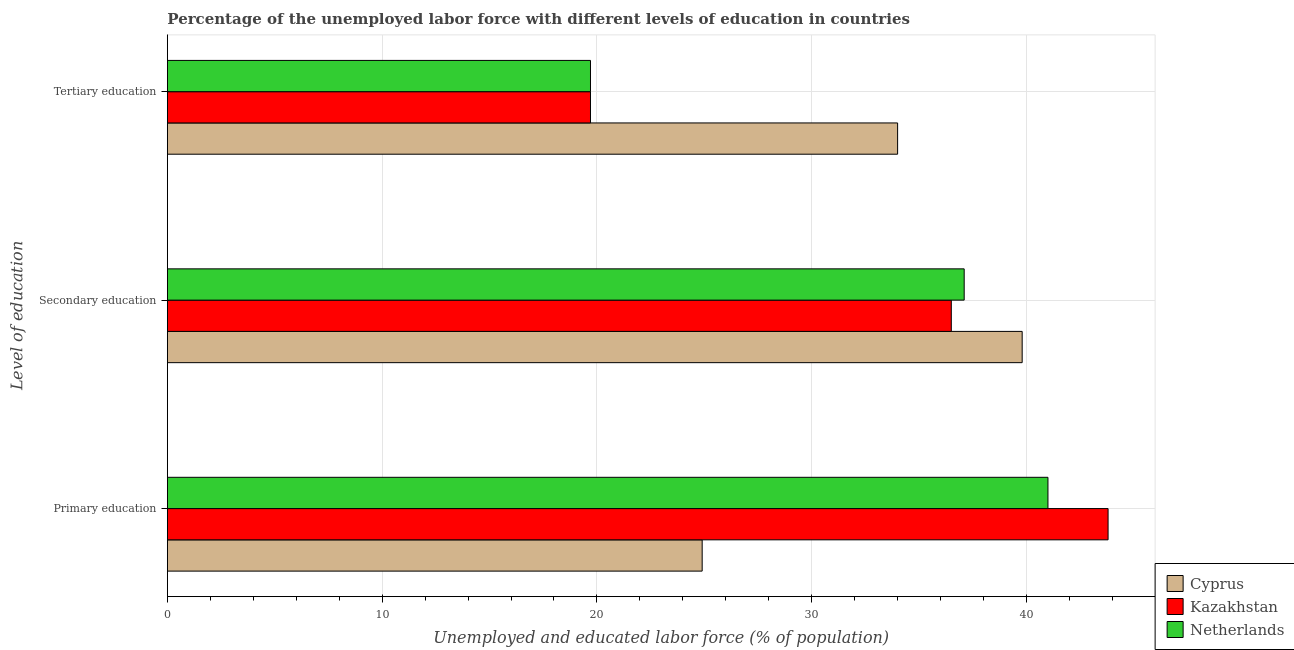How many groups of bars are there?
Offer a terse response. 3. Are the number of bars per tick equal to the number of legend labels?
Provide a succinct answer. Yes. How many bars are there on the 3rd tick from the top?
Provide a succinct answer. 3. What is the label of the 3rd group of bars from the top?
Keep it short and to the point. Primary education. What is the percentage of labor force who received secondary education in Netherlands?
Provide a succinct answer. 37.1. Across all countries, what is the maximum percentage of labor force who received secondary education?
Keep it short and to the point. 39.8. Across all countries, what is the minimum percentage of labor force who received secondary education?
Provide a succinct answer. 36.5. In which country was the percentage of labor force who received secondary education maximum?
Offer a very short reply. Cyprus. In which country was the percentage of labor force who received secondary education minimum?
Ensure brevity in your answer.  Kazakhstan. What is the total percentage of labor force who received secondary education in the graph?
Your response must be concise. 113.4. What is the difference between the percentage of labor force who received primary education in Kazakhstan and that in Netherlands?
Ensure brevity in your answer.  2.8. What is the difference between the percentage of labor force who received primary education in Cyprus and the percentage of labor force who received secondary education in Kazakhstan?
Ensure brevity in your answer.  -11.6. What is the average percentage of labor force who received primary education per country?
Your response must be concise. 36.57. What is the difference between the percentage of labor force who received primary education and percentage of labor force who received secondary education in Netherlands?
Give a very brief answer. 3.9. In how many countries, is the percentage of labor force who received primary education greater than 36 %?
Offer a terse response. 2. What is the ratio of the percentage of labor force who received primary education in Kazakhstan to that in Cyprus?
Keep it short and to the point. 1.76. Is the difference between the percentage of labor force who received tertiary education in Netherlands and Kazakhstan greater than the difference between the percentage of labor force who received secondary education in Netherlands and Kazakhstan?
Your answer should be compact. No. What is the difference between the highest and the second highest percentage of labor force who received secondary education?
Offer a terse response. 2.7. What is the difference between the highest and the lowest percentage of labor force who received primary education?
Offer a very short reply. 18.9. In how many countries, is the percentage of labor force who received primary education greater than the average percentage of labor force who received primary education taken over all countries?
Offer a very short reply. 2. What does the 2nd bar from the top in Secondary education represents?
Make the answer very short. Kazakhstan. What does the 2nd bar from the bottom in Primary education represents?
Give a very brief answer. Kazakhstan. Are all the bars in the graph horizontal?
Your answer should be very brief. Yes. How many countries are there in the graph?
Your response must be concise. 3. Does the graph contain any zero values?
Provide a succinct answer. No. How many legend labels are there?
Offer a very short reply. 3. What is the title of the graph?
Give a very brief answer. Percentage of the unemployed labor force with different levels of education in countries. Does "Puerto Rico" appear as one of the legend labels in the graph?
Offer a very short reply. No. What is the label or title of the X-axis?
Ensure brevity in your answer.  Unemployed and educated labor force (% of population). What is the label or title of the Y-axis?
Keep it short and to the point. Level of education. What is the Unemployed and educated labor force (% of population) of Cyprus in Primary education?
Your response must be concise. 24.9. What is the Unemployed and educated labor force (% of population) of Kazakhstan in Primary education?
Offer a very short reply. 43.8. What is the Unemployed and educated labor force (% of population) in Cyprus in Secondary education?
Ensure brevity in your answer.  39.8. What is the Unemployed and educated labor force (% of population) of Kazakhstan in Secondary education?
Offer a terse response. 36.5. What is the Unemployed and educated labor force (% of population) of Netherlands in Secondary education?
Ensure brevity in your answer.  37.1. What is the Unemployed and educated labor force (% of population) in Cyprus in Tertiary education?
Give a very brief answer. 34. What is the Unemployed and educated labor force (% of population) in Kazakhstan in Tertiary education?
Provide a short and direct response. 19.7. What is the Unemployed and educated labor force (% of population) of Netherlands in Tertiary education?
Your response must be concise. 19.7. Across all Level of education, what is the maximum Unemployed and educated labor force (% of population) in Cyprus?
Keep it short and to the point. 39.8. Across all Level of education, what is the maximum Unemployed and educated labor force (% of population) of Kazakhstan?
Offer a very short reply. 43.8. Across all Level of education, what is the minimum Unemployed and educated labor force (% of population) of Cyprus?
Provide a succinct answer. 24.9. Across all Level of education, what is the minimum Unemployed and educated labor force (% of population) in Kazakhstan?
Make the answer very short. 19.7. Across all Level of education, what is the minimum Unemployed and educated labor force (% of population) of Netherlands?
Your answer should be compact. 19.7. What is the total Unemployed and educated labor force (% of population) in Cyprus in the graph?
Provide a succinct answer. 98.7. What is the total Unemployed and educated labor force (% of population) of Netherlands in the graph?
Keep it short and to the point. 97.8. What is the difference between the Unemployed and educated labor force (% of population) of Cyprus in Primary education and that in Secondary education?
Give a very brief answer. -14.9. What is the difference between the Unemployed and educated labor force (% of population) in Kazakhstan in Primary education and that in Tertiary education?
Your response must be concise. 24.1. What is the difference between the Unemployed and educated labor force (% of population) of Netherlands in Primary education and that in Tertiary education?
Ensure brevity in your answer.  21.3. What is the difference between the Unemployed and educated labor force (% of population) in Kazakhstan in Secondary education and that in Tertiary education?
Your answer should be compact. 16.8. What is the difference between the Unemployed and educated labor force (% of population) in Netherlands in Secondary education and that in Tertiary education?
Provide a short and direct response. 17.4. What is the difference between the Unemployed and educated labor force (% of population) of Cyprus in Primary education and the Unemployed and educated labor force (% of population) of Netherlands in Secondary education?
Offer a very short reply. -12.2. What is the difference between the Unemployed and educated labor force (% of population) in Kazakhstan in Primary education and the Unemployed and educated labor force (% of population) in Netherlands in Secondary education?
Your answer should be compact. 6.7. What is the difference between the Unemployed and educated labor force (% of population) in Cyprus in Primary education and the Unemployed and educated labor force (% of population) in Kazakhstan in Tertiary education?
Your response must be concise. 5.2. What is the difference between the Unemployed and educated labor force (% of population) in Cyprus in Primary education and the Unemployed and educated labor force (% of population) in Netherlands in Tertiary education?
Offer a terse response. 5.2. What is the difference between the Unemployed and educated labor force (% of population) in Kazakhstan in Primary education and the Unemployed and educated labor force (% of population) in Netherlands in Tertiary education?
Give a very brief answer. 24.1. What is the difference between the Unemployed and educated labor force (% of population) of Cyprus in Secondary education and the Unemployed and educated labor force (% of population) of Kazakhstan in Tertiary education?
Keep it short and to the point. 20.1. What is the difference between the Unemployed and educated labor force (% of population) of Cyprus in Secondary education and the Unemployed and educated labor force (% of population) of Netherlands in Tertiary education?
Your answer should be compact. 20.1. What is the difference between the Unemployed and educated labor force (% of population) of Kazakhstan in Secondary education and the Unemployed and educated labor force (% of population) of Netherlands in Tertiary education?
Your response must be concise. 16.8. What is the average Unemployed and educated labor force (% of population) in Cyprus per Level of education?
Your answer should be compact. 32.9. What is the average Unemployed and educated labor force (% of population) in Kazakhstan per Level of education?
Provide a succinct answer. 33.33. What is the average Unemployed and educated labor force (% of population) in Netherlands per Level of education?
Offer a terse response. 32.6. What is the difference between the Unemployed and educated labor force (% of population) of Cyprus and Unemployed and educated labor force (% of population) of Kazakhstan in Primary education?
Offer a terse response. -18.9. What is the difference between the Unemployed and educated labor force (% of population) in Cyprus and Unemployed and educated labor force (% of population) in Netherlands in Primary education?
Your answer should be very brief. -16.1. What is the difference between the Unemployed and educated labor force (% of population) in Kazakhstan and Unemployed and educated labor force (% of population) in Netherlands in Primary education?
Offer a very short reply. 2.8. What is the difference between the Unemployed and educated labor force (% of population) in Cyprus and Unemployed and educated labor force (% of population) in Netherlands in Secondary education?
Your response must be concise. 2.7. What is the difference between the Unemployed and educated labor force (% of population) in Kazakhstan and Unemployed and educated labor force (% of population) in Netherlands in Secondary education?
Provide a short and direct response. -0.6. What is the difference between the Unemployed and educated labor force (% of population) in Cyprus and Unemployed and educated labor force (% of population) in Kazakhstan in Tertiary education?
Provide a succinct answer. 14.3. What is the ratio of the Unemployed and educated labor force (% of population) of Cyprus in Primary education to that in Secondary education?
Your response must be concise. 0.63. What is the ratio of the Unemployed and educated labor force (% of population) of Netherlands in Primary education to that in Secondary education?
Provide a short and direct response. 1.11. What is the ratio of the Unemployed and educated labor force (% of population) of Cyprus in Primary education to that in Tertiary education?
Provide a short and direct response. 0.73. What is the ratio of the Unemployed and educated labor force (% of population) of Kazakhstan in Primary education to that in Tertiary education?
Your answer should be compact. 2.22. What is the ratio of the Unemployed and educated labor force (% of population) in Netherlands in Primary education to that in Tertiary education?
Ensure brevity in your answer.  2.08. What is the ratio of the Unemployed and educated labor force (% of population) of Cyprus in Secondary education to that in Tertiary education?
Give a very brief answer. 1.17. What is the ratio of the Unemployed and educated labor force (% of population) in Kazakhstan in Secondary education to that in Tertiary education?
Offer a very short reply. 1.85. What is the ratio of the Unemployed and educated labor force (% of population) of Netherlands in Secondary education to that in Tertiary education?
Offer a terse response. 1.88. What is the difference between the highest and the lowest Unemployed and educated labor force (% of population) in Kazakhstan?
Your answer should be very brief. 24.1. What is the difference between the highest and the lowest Unemployed and educated labor force (% of population) in Netherlands?
Your response must be concise. 21.3. 